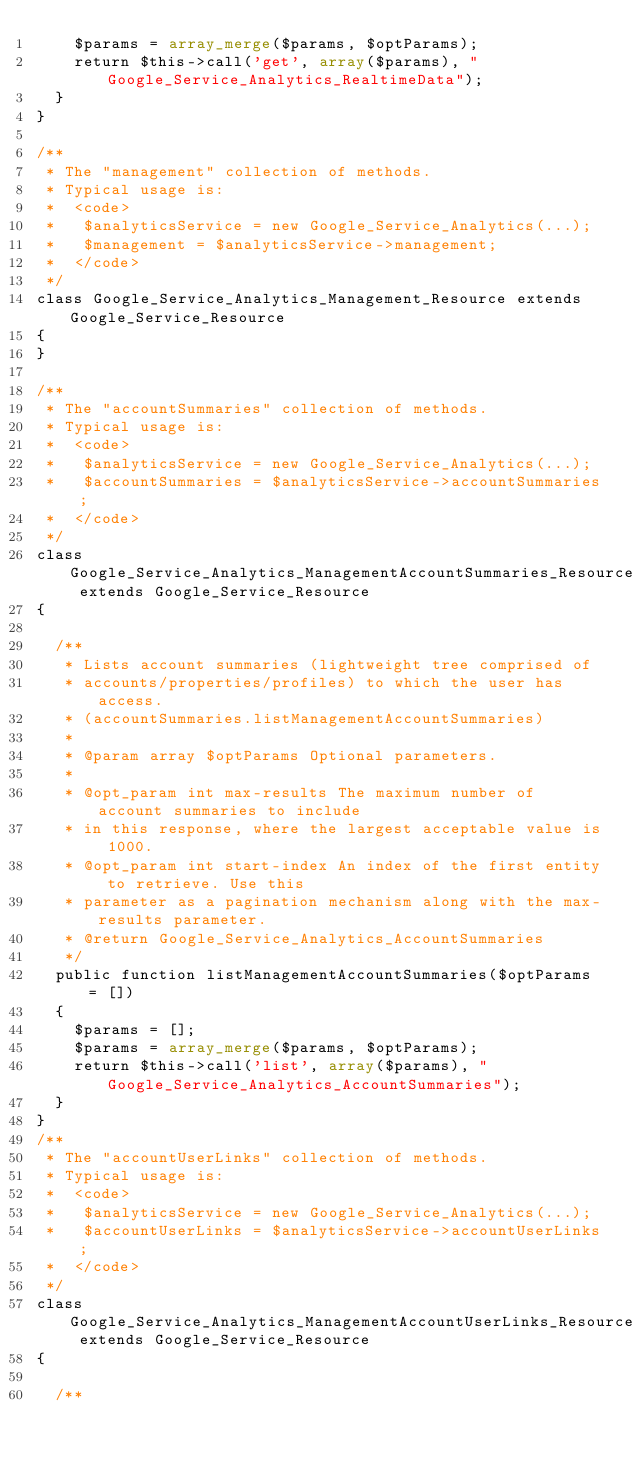Convert code to text. <code><loc_0><loc_0><loc_500><loc_500><_PHP_>    $params = array_merge($params, $optParams);
    return $this->call('get', array($params), "Google_Service_Analytics_RealtimeData");
  }
}

/**
 * The "management" collection of methods.
 * Typical usage is:
 *  <code>
 *   $analyticsService = new Google_Service_Analytics(...);
 *   $management = $analyticsService->management;
 *  </code>
 */
class Google_Service_Analytics_Management_Resource extends Google_Service_Resource
{
}

/**
 * The "accountSummaries" collection of methods.
 * Typical usage is:
 *  <code>
 *   $analyticsService = new Google_Service_Analytics(...);
 *   $accountSummaries = $analyticsService->accountSummaries;
 *  </code>
 */
class Google_Service_Analytics_ManagementAccountSummaries_Resource extends Google_Service_Resource
{

  /**
   * Lists account summaries (lightweight tree comprised of
   * accounts/properties/profiles) to which the user has access.
   * (accountSummaries.listManagementAccountSummaries)
   *
   * @param array $optParams Optional parameters.
   *
   * @opt_param int max-results The maximum number of account summaries to include
   * in this response, where the largest acceptable value is 1000.
   * @opt_param int start-index An index of the first entity to retrieve. Use this
   * parameter as a pagination mechanism along with the max-results parameter.
   * @return Google_Service_Analytics_AccountSummaries
   */
  public function listManagementAccountSummaries($optParams = [])
  {
    $params = [];
    $params = array_merge($params, $optParams);
    return $this->call('list', array($params), "Google_Service_Analytics_AccountSummaries");
  }
}
/**
 * The "accountUserLinks" collection of methods.
 * Typical usage is:
 *  <code>
 *   $analyticsService = new Google_Service_Analytics(...);
 *   $accountUserLinks = $analyticsService->accountUserLinks;
 *  </code>
 */
class Google_Service_Analytics_ManagementAccountUserLinks_Resource extends Google_Service_Resource
{

  /**</code> 